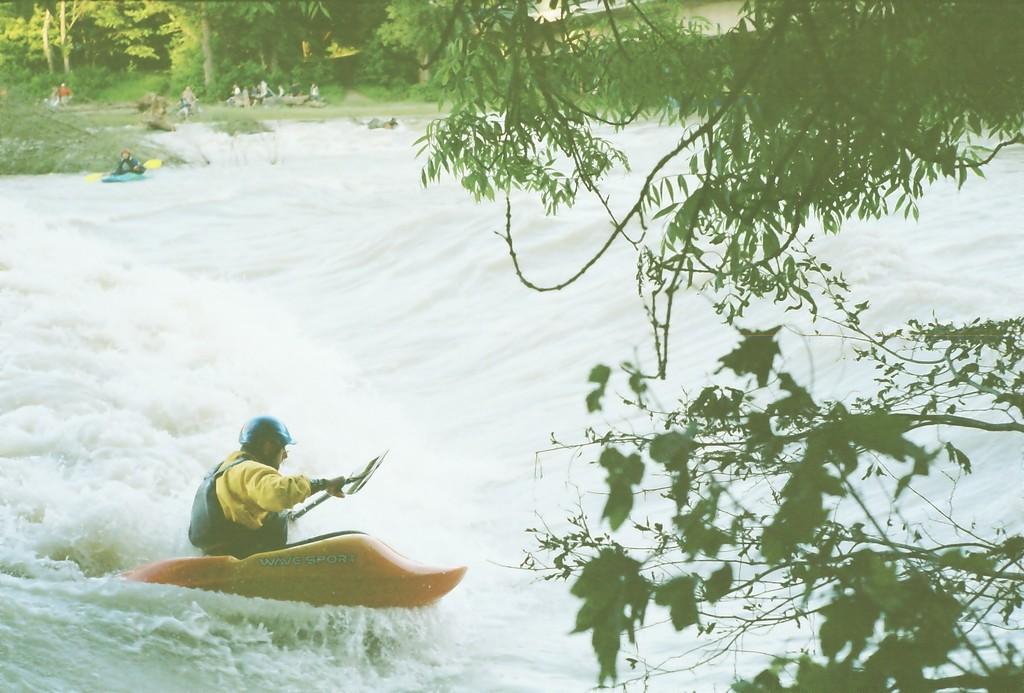Could you give a brief overview of what you see in this image? In this image we can see persons on kayak and holding paddles. They are on water. There are trees. On the right side there are branches. 